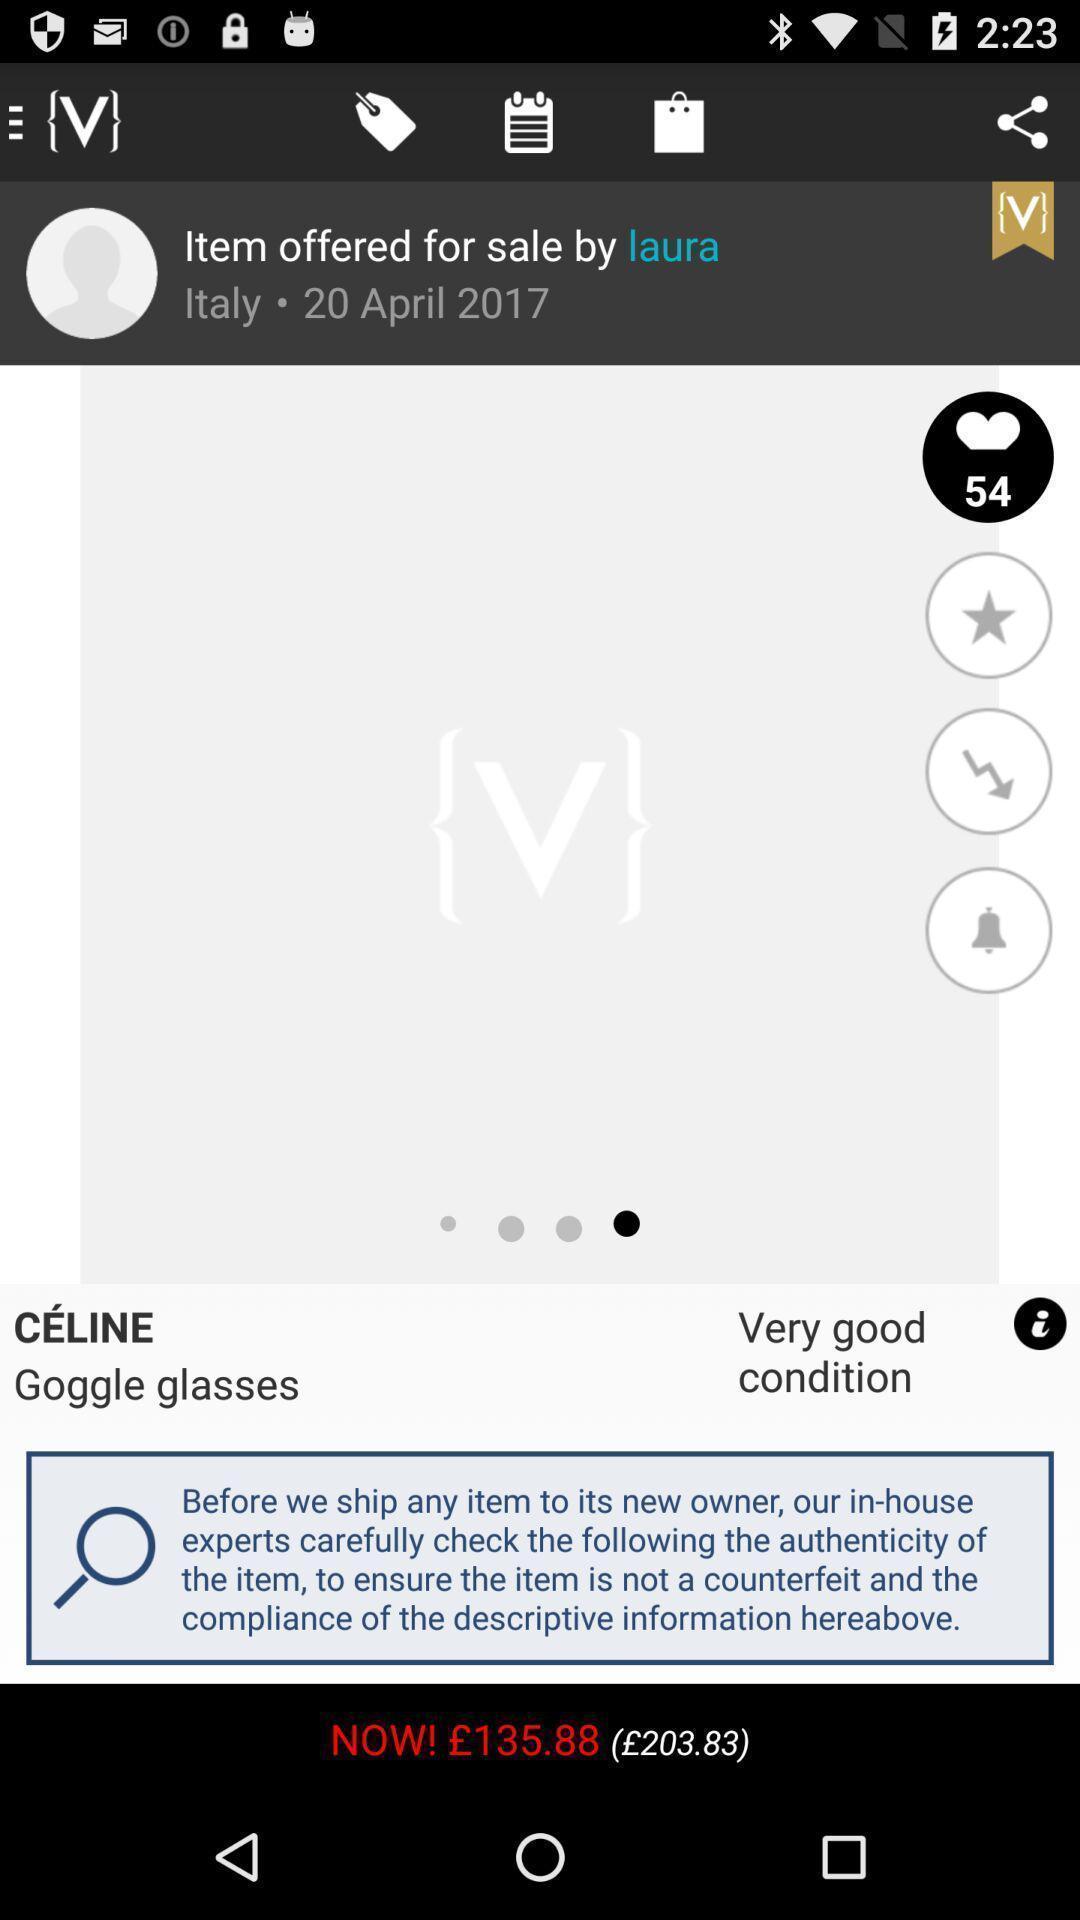Describe the visual elements of this screenshot. Product from a shopping app. 